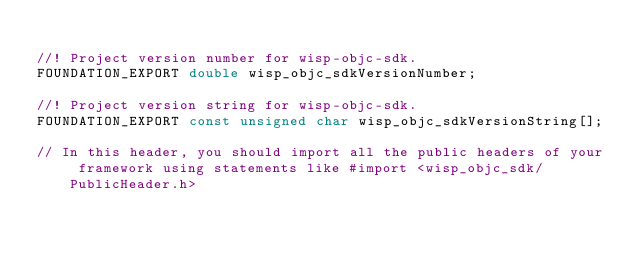<code> <loc_0><loc_0><loc_500><loc_500><_C_>
//! Project version number for wisp-objc-sdk.
FOUNDATION_EXPORT double wisp_objc_sdkVersionNumber;

//! Project version string for wisp-objc-sdk.
FOUNDATION_EXPORT const unsigned char wisp_objc_sdkVersionString[];

// In this header, you should import all the public headers of your framework using statements like #import <wisp_objc_sdk/PublicHeader.h>


</code> 